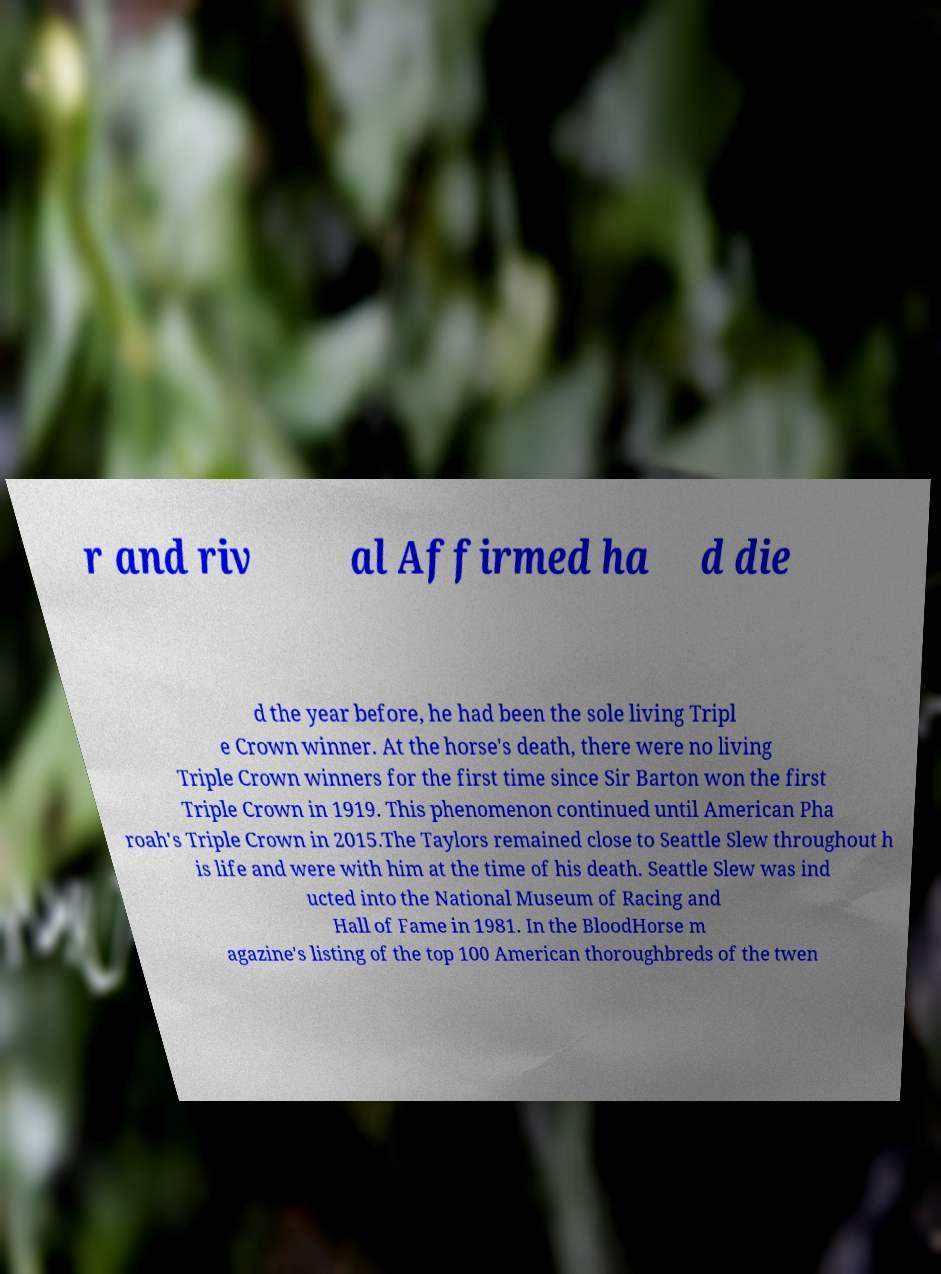Can you read and provide the text displayed in the image?This photo seems to have some interesting text. Can you extract and type it out for me? r and riv al Affirmed ha d die d the year before, he had been the sole living Tripl e Crown winner. At the horse's death, there were no living Triple Crown winners for the first time since Sir Barton won the first Triple Crown in 1919. This phenomenon continued until American Pha roah's Triple Crown in 2015.The Taylors remained close to Seattle Slew throughout h is life and were with him at the time of his death. Seattle Slew was ind ucted into the National Museum of Racing and Hall of Fame in 1981. In the BloodHorse m agazine's listing of the top 100 American thoroughbreds of the twen 